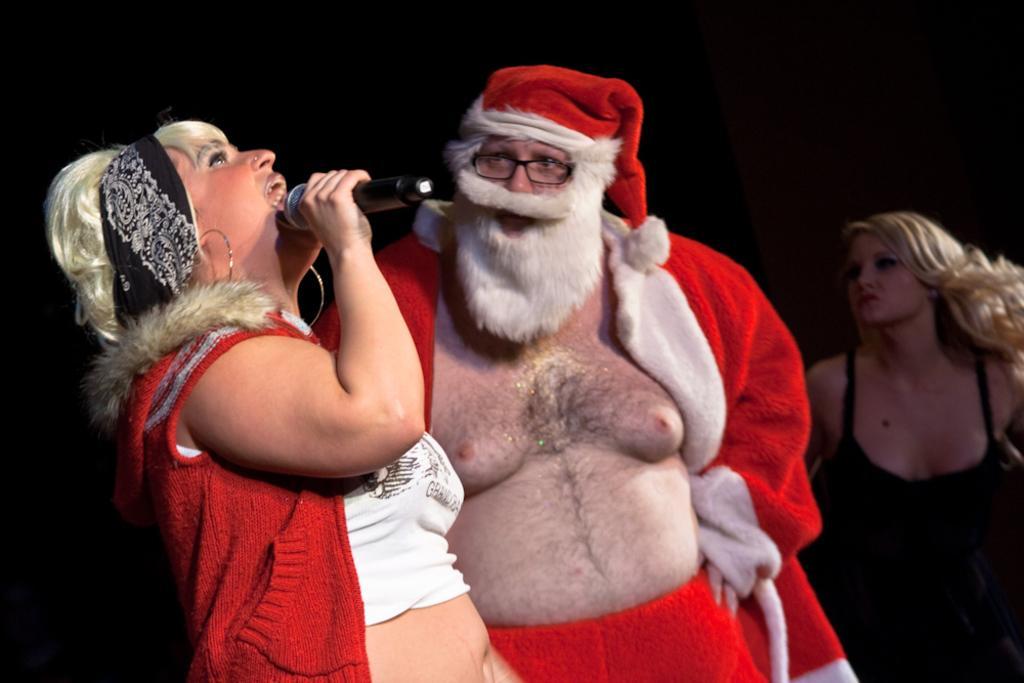Can you describe this image briefly? This picture describes about group of people, on the left side of the image we can see a woman she is holding a microphone, beside her we can find a man, he wore spectacles and we can see dark background. 